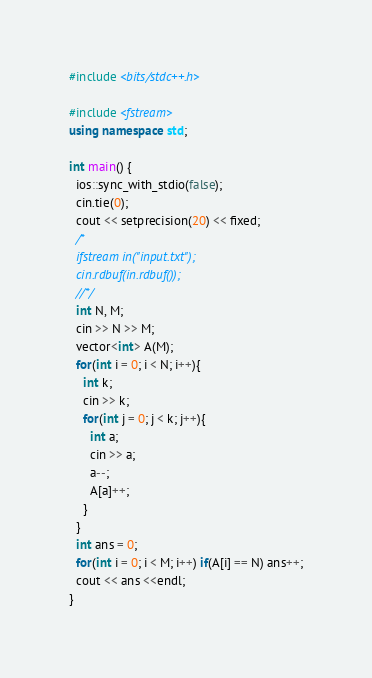Convert code to text. <code><loc_0><loc_0><loc_500><loc_500><_C++_>#include <bits/stdc++.h>

#include <fstream>
using namespace std;

int main() {
  ios::sync_with_stdio(false);
  cin.tie(0);
  cout << setprecision(20) << fixed;
  /*
  ifstream in("input.txt");
  cin.rdbuf(in.rdbuf());
  //*/
  int N, M;
  cin >> N >> M;
  vector<int> A(M);
  for(int i = 0; i < N; i++){
    int k;
    cin >> k;
    for(int j = 0; j < k; j++){
      int a;
      cin >> a;
      a--;
      A[a]++;
    }
  }
  int ans = 0;
  for(int i = 0; i < M; i++) if(A[i] == N) ans++;
  cout << ans <<endl;
}
</code> 